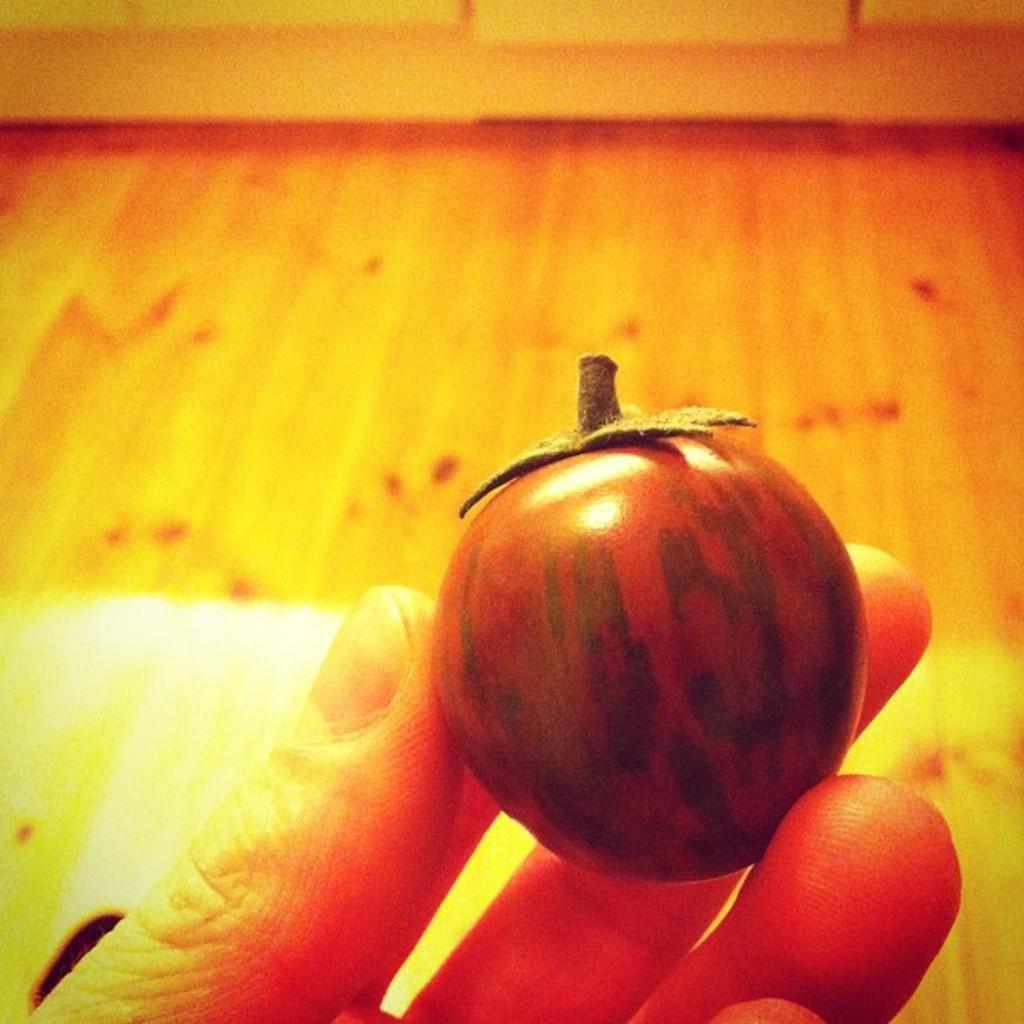Can you describe this image briefly? We can see vegetable hold with hand. We can see floor. 